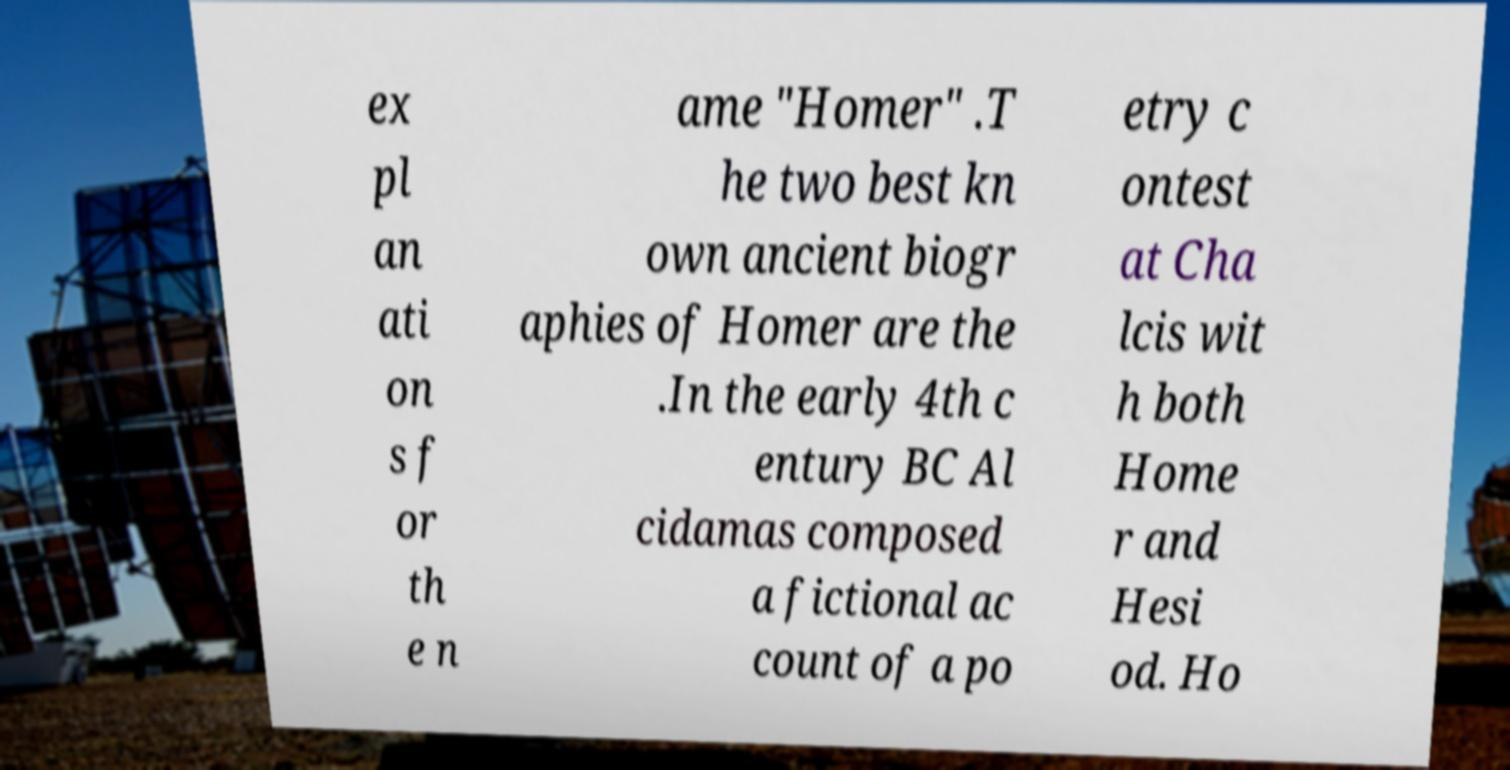There's text embedded in this image that I need extracted. Can you transcribe it verbatim? ex pl an ati on s f or th e n ame "Homer" .T he two best kn own ancient biogr aphies of Homer are the .In the early 4th c entury BC Al cidamas composed a fictional ac count of a po etry c ontest at Cha lcis wit h both Home r and Hesi od. Ho 